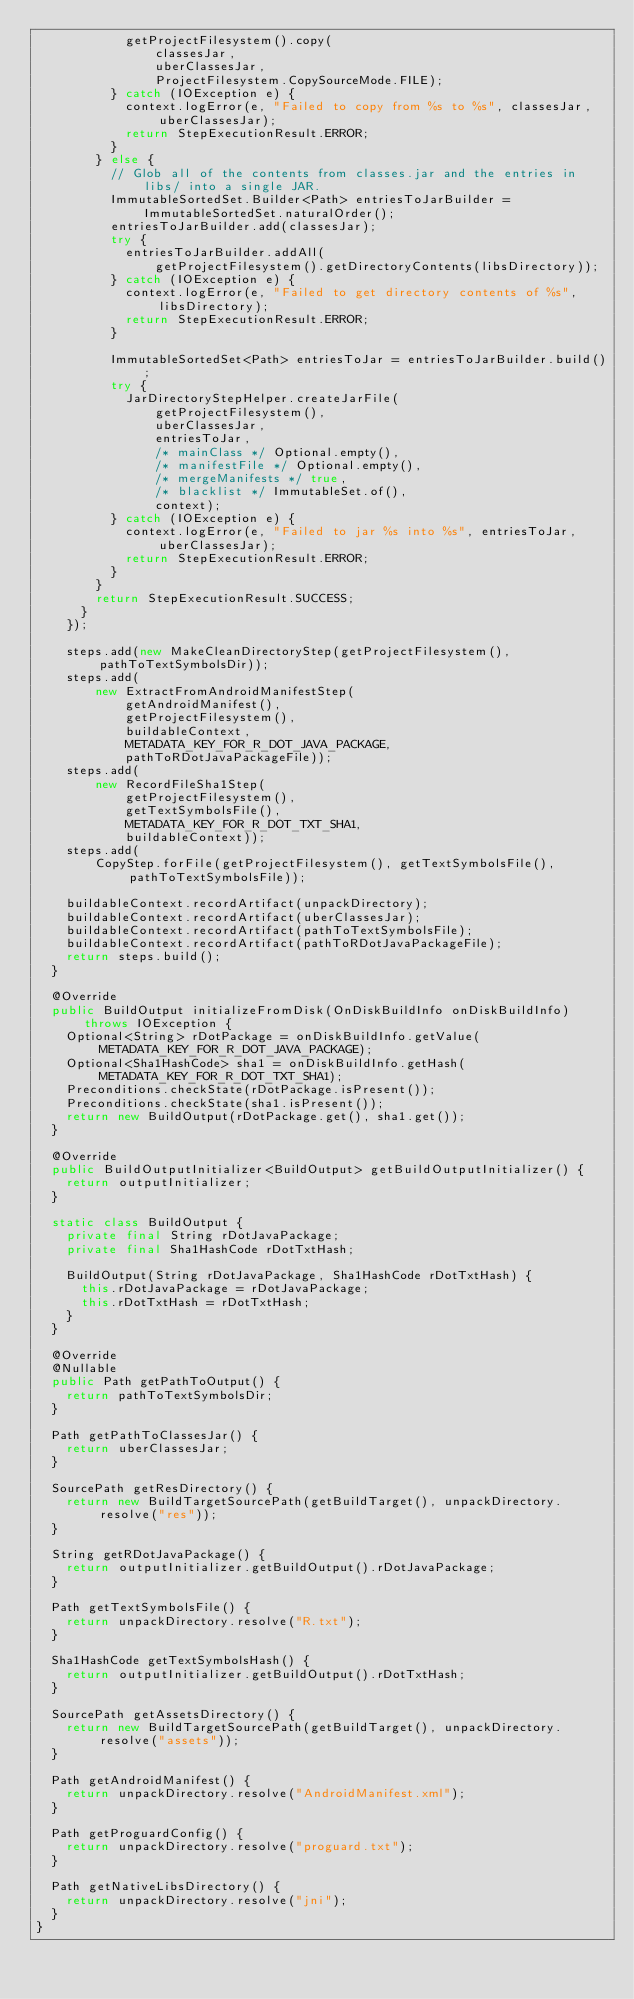Convert code to text. <code><loc_0><loc_0><loc_500><loc_500><_Java_>            getProjectFilesystem().copy(
                classesJar,
                uberClassesJar,
                ProjectFilesystem.CopySourceMode.FILE);
          } catch (IOException e) {
            context.logError(e, "Failed to copy from %s to %s", classesJar, uberClassesJar);
            return StepExecutionResult.ERROR;
          }
        } else {
          // Glob all of the contents from classes.jar and the entries in libs/ into a single JAR.
          ImmutableSortedSet.Builder<Path> entriesToJarBuilder = ImmutableSortedSet.naturalOrder();
          entriesToJarBuilder.add(classesJar);
          try {
            entriesToJarBuilder.addAll(
                getProjectFilesystem().getDirectoryContents(libsDirectory));
          } catch (IOException e) {
            context.logError(e, "Failed to get directory contents of %s", libsDirectory);
            return StepExecutionResult.ERROR;
          }

          ImmutableSortedSet<Path> entriesToJar = entriesToJarBuilder.build();
          try {
            JarDirectoryStepHelper.createJarFile(
                getProjectFilesystem(),
                uberClassesJar,
                entriesToJar,
                /* mainClass */ Optional.empty(),
                /* manifestFile */ Optional.empty(),
                /* mergeManifests */ true,
                /* blacklist */ ImmutableSet.of(),
                context);
          } catch (IOException e) {
            context.logError(e, "Failed to jar %s into %s", entriesToJar, uberClassesJar);
            return StepExecutionResult.ERROR;
          }
        }
        return StepExecutionResult.SUCCESS;
      }
    });

    steps.add(new MakeCleanDirectoryStep(getProjectFilesystem(), pathToTextSymbolsDir));
    steps.add(
        new ExtractFromAndroidManifestStep(
            getAndroidManifest(),
            getProjectFilesystem(),
            buildableContext,
            METADATA_KEY_FOR_R_DOT_JAVA_PACKAGE,
            pathToRDotJavaPackageFile));
    steps.add(
        new RecordFileSha1Step(
            getProjectFilesystem(),
            getTextSymbolsFile(),
            METADATA_KEY_FOR_R_DOT_TXT_SHA1,
            buildableContext));
    steps.add(
        CopyStep.forFile(getProjectFilesystem(), getTextSymbolsFile(), pathToTextSymbolsFile));

    buildableContext.recordArtifact(unpackDirectory);
    buildableContext.recordArtifact(uberClassesJar);
    buildableContext.recordArtifact(pathToTextSymbolsFile);
    buildableContext.recordArtifact(pathToRDotJavaPackageFile);
    return steps.build();
  }

  @Override
  public BuildOutput initializeFromDisk(OnDiskBuildInfo onDiskBuildInfo) throws IOException {
    Optional<String> rDotPackage = onDiskBuildInfo.getValue(METADATA_KEY_FOR_R_DOT_JAVA_PACKAGE);
    Optional<Sha1HashCode> sha1 = onDiskBuildInfo.getHash(METADATA_KEY_FOR_R_DOT_TXT_SHA1);
    Preconditions.checkState(rDotPackage.isPresent());
    Preconditions.checkState(sha1.isPresent());
    return new BuildOutput(rDotPackage.get(), sha1.get());
  }

  @Override
  public BuildOutputInitializer<BuildOutput> getBuildOutputInitializer() {
    return outputInitializer;
  }

  static class BuildOutput {
    private final String rDotJavaPackage;
    private final Sha1HashCode rDotTxtHash;

    BuildOutput(String rDotJavaPackage, Sha1HashCode rDotTxtHash) {
      this.rDotJavaPackage = rDotJavaPackage;
      this.rDotTxtHash = rDotTxtHash;
    }
  }

  @Override
  @Nullable
  public Path getPathToOutput() {
    return pathToTextSymbolsDir;
  }

  Path getPathToClassesJar() {
    return uberClassesJar;
  }

  SourcePath getResDirectory() {
    return new BuildTargetSourcePath(getBuildTarget(), unpackDirectory.resolve("res"));
  }

  String getRDotJavaPackage() {
    return outputInitializer.getBuildOutput().rDotJavaPackage;
  }

  Path getTextSymbolsFile() {
    return unpackDirectory.resolve("R.txt");
  }

  Sha1HashCode getTextSymbolsHash() {
    return outputInitializer.getBuildOutput().rDotTxtHash;
  }

  SourcePath getAssetsDirectory() {
    return new BuildTargetSourcePath(getBuildTarget(), unpackDirectory.resolve("assets"));
  }

  Path getAndroidManifest() {
    return unpackDirectory.resolve("AndroidManifest.xml");
  }

  Path getProguardConfig() {
    return unpackDirectory.resolve("proguard.txt");
  }

  Path getNativeLibsDirectory() {
    return unpackDirectory.resolve("jni");
  }
}
</code> 